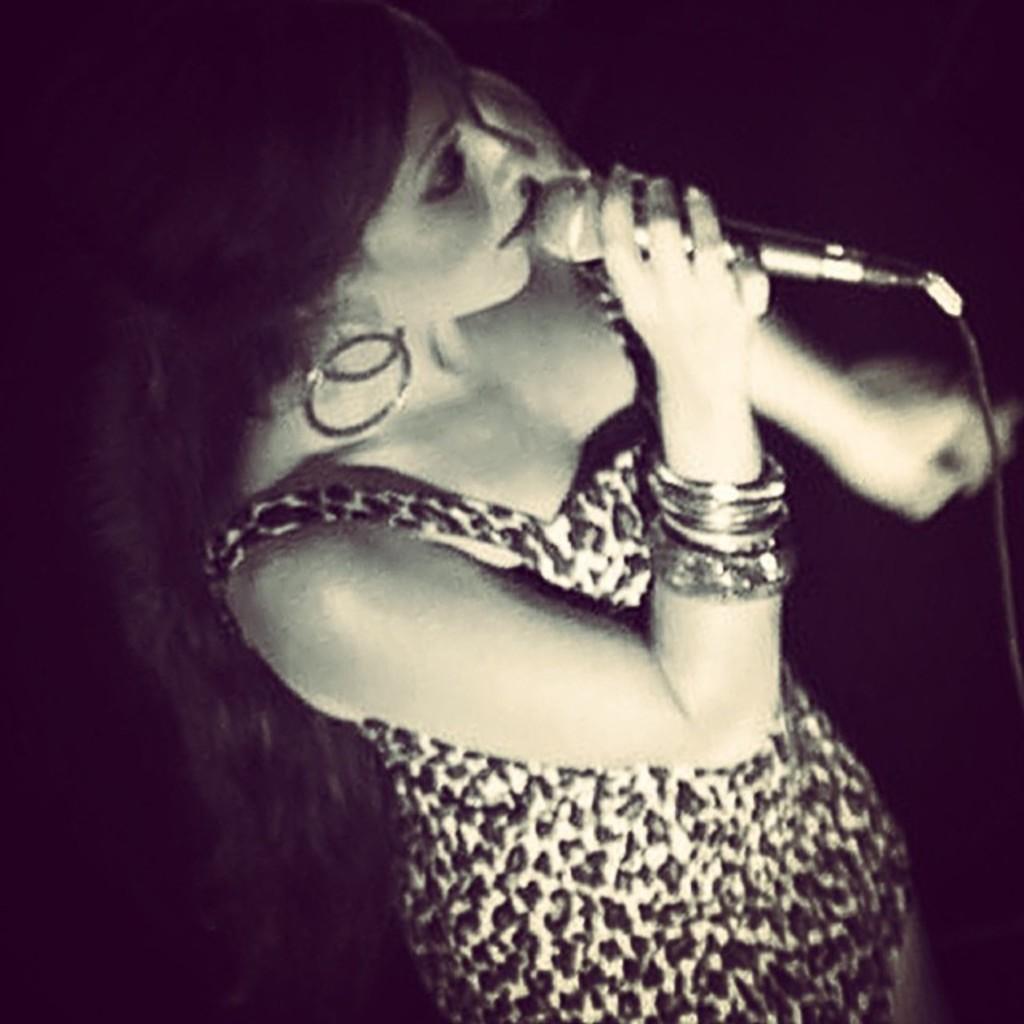Can you describe this image briefly? In this image we can see one woman standing, holding a microphone with wire and singing. The background is dark. 